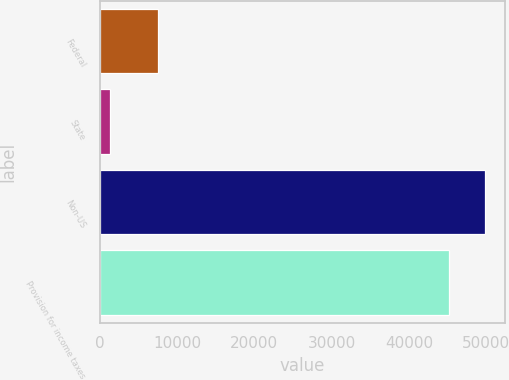<chart> <loc_0><loc_0><loc_500><loc_500><bar_chart><fcel>Federal<fcel>State<fcel>Non-US<fcel>Provision for income taxes<nl><fcel>7507<fcel>1370<fcel>49868.1<fcel>45183<nl></chart> 